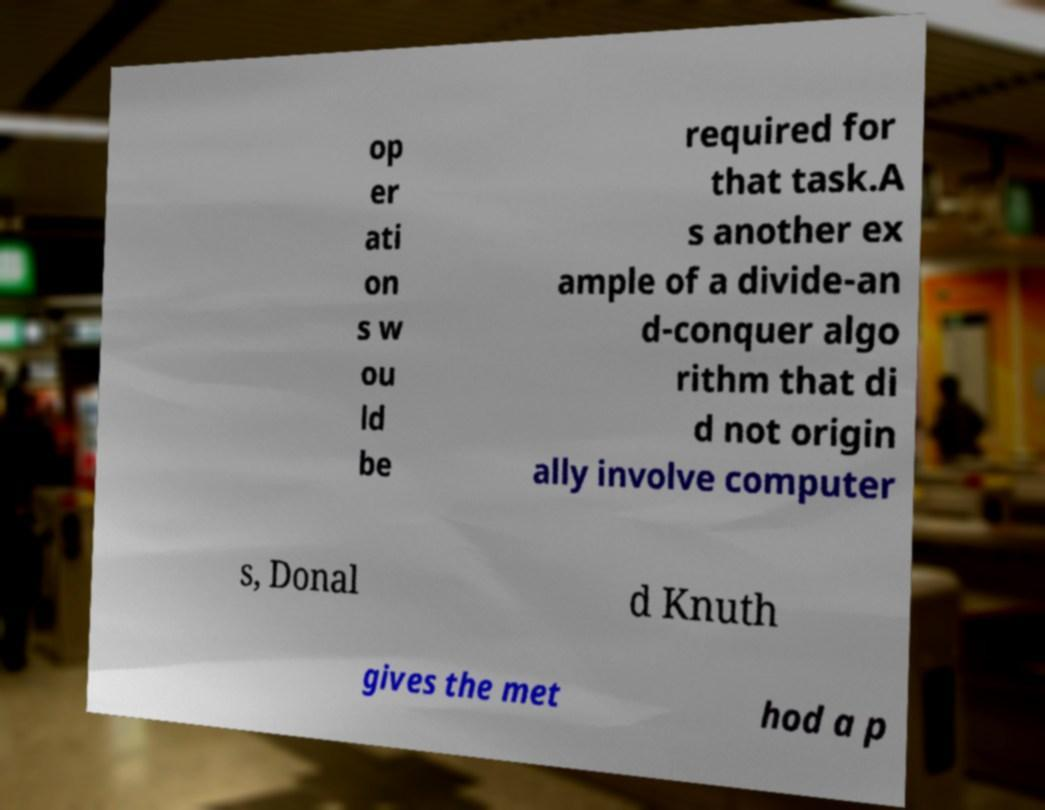Please read and relay the text visible in this image. What does it say? op er ati on s w ou ld be required for that task.A s another ex ample of a divide-an d-conquer algo rithm that di d not origin ally involve computer s, Donal d Knuth gives the met hod a p 